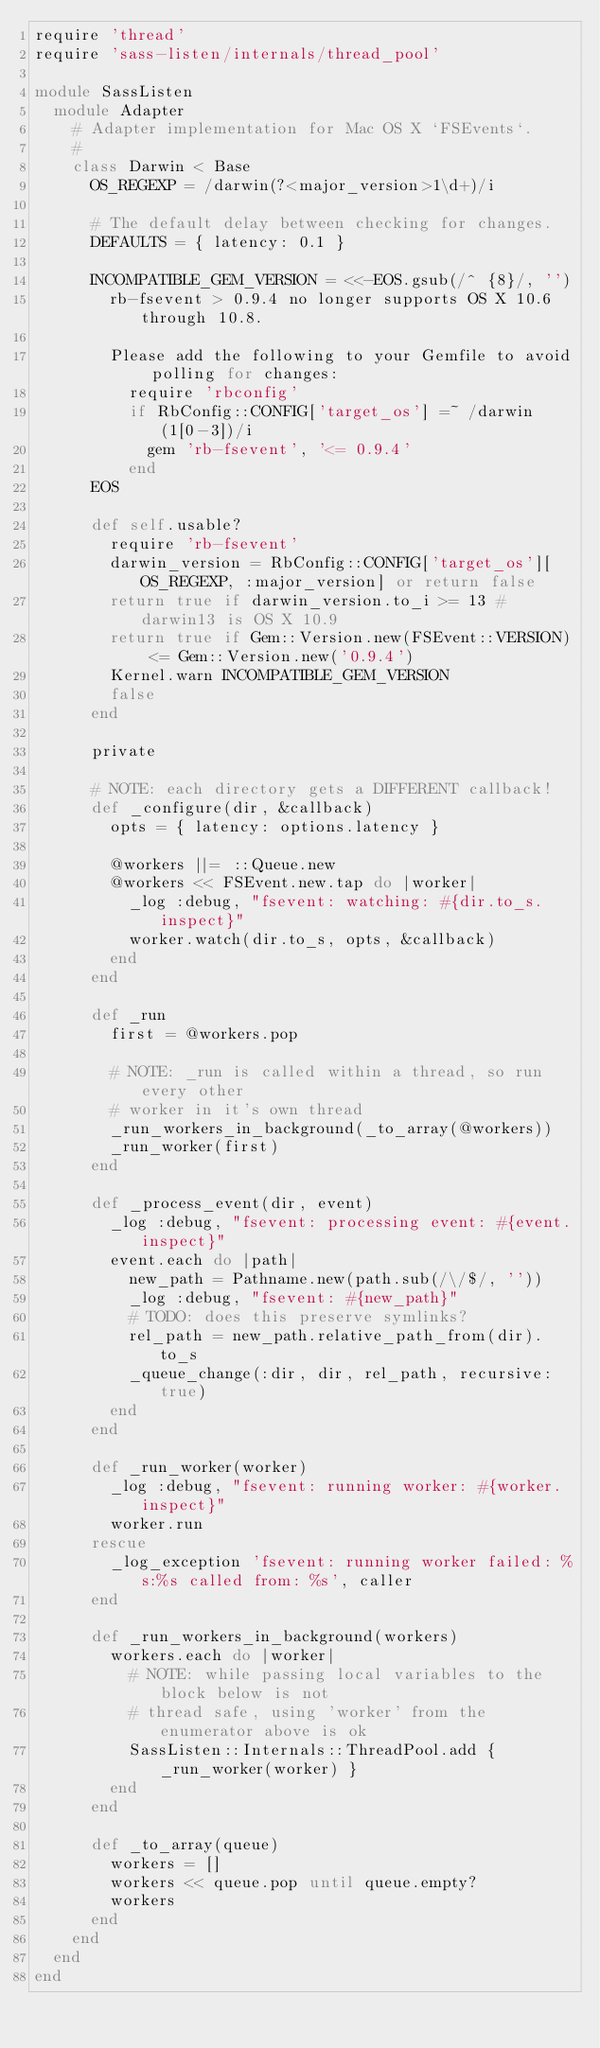<code> <loc_0><loc_0><loc_500><loc_500><_Ruby_>require 'thread'
require 'sass-listen/internals/thread_pool'

module SassListen
  module Adapter
    # Adapter implementation for Mac OS X `FSEvents`.
    #
    class Darwin < Base
      OS_REGEXP = /darwin(?<major_version>1\d+)/i

      # The default delay between checking for changes.
      DEFAULTS = { latency: 0.1 }

      INCOMPATIBLE_GEM_VERSION = <<-EOS.gsub(/^ {8}/, '')
        rb-fsevent > 0.9.4 no longer supports OS X 10.6 through 10.8.

        Please add the following to your Gemfile to avoid polling for changes:
          require 'rbconfig'
          if RbConfig::CONFIG['target_os'] =~ /darwin(1[0-3])/i
            gem 'rb-fsevent', '<= 0.9.4'
          end
      EOS

      def self.usable?
        require 'rb-fsevent'
        darwin_version = RbConfig::CONFIG['target_os'][OS_REGEXP, :major_version] or return false
        return true if darwin_version.to_i >= 13 # darwin13 is OS X 10.9
        return true if Gem::Version.new(FSEvent::VERSION) <= Gem::Version.new('0.9.4')
        Kernel.warn INCOMPATIBLE_GEM_VERSION
        false
      end

      private

      # NOTE: each directory gets a DIFFERENT callback!
      def _configure(dir, &callback)
        opts = { latency: options.latency }

        @workers ||= ::Queue.new
        @workers << FSEvent.new.tap do |worker|
          _log :debug, "fsevent: watching: #{dir.to_s.inspect}"
          worker.watch(dir.to_s, opts, &callback)
        end
      end

      def _run
        first = @workers.pop

        # NOTE: _run is called within a thread, so run every other
        # worker in it's own thread
        _run_workers_in_background(_to_array(@workers))
        _run_worker(first)
      end

      def _process_event(dir, event)
        _log :debug, "fsevent: processing event: #{event.inspect}"
        event.each do |path|
          new_path = Pathname.new(path.sub(/\/$/, ''))
          _log :debug, "fsevent: #{new_path}"
          # TODO: does this preserve symlinks?
          rel_path = new_path.relative_path_from(dir).to_s
          _queue_change(:dir, dir, rel_path, recursive: true)
        end
      end

      def _run_worker(worker)
        _log :debug, "fsevent: running worker: #{worker.inspect}"
        worker.run
      rescue
        _log_exception 'fsevent: running worker failed: %s:%s called from: %s', caller
      end

      def _run_workers_in_background(workers)
        workers.each do |worker|
          # NOTE: while passing local variables to the block below is not
          # thread safe, using 'worker' from the enumerator above is ok
          SassListen::Internals::ThreadPool.add { _run_worker(worker) }
        end
      end

      def _to_array(queue)
        workers = []
        workers << queue.pop until queue.empty?
        workers
      end
    end
  end
end
</code> 